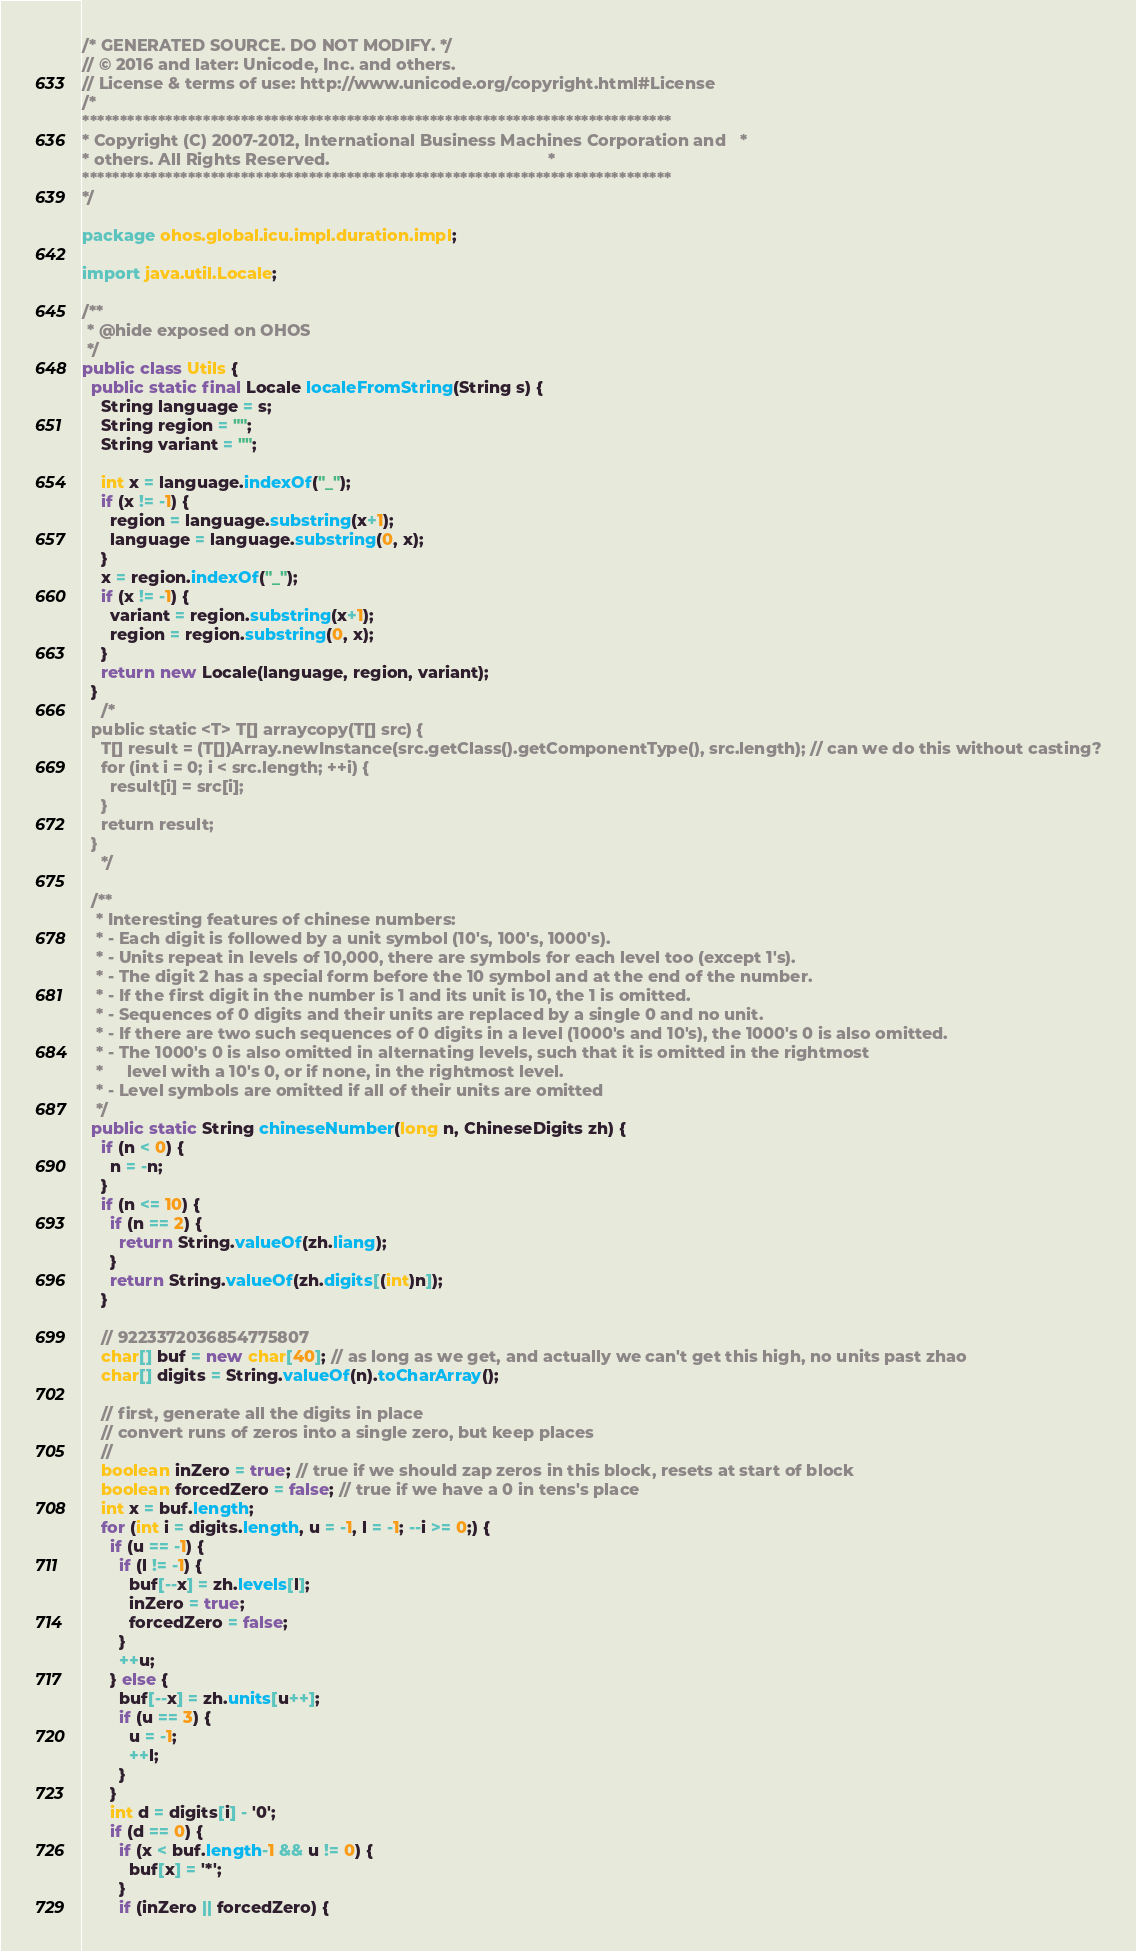<code> <loc_0><loc_0><loc_500><loc_500><_Java_>/* GENERATED SOURCE. DO NOT MODIFY. */
// © 2016 and later: Unicode, Inc. and others.
// License & terms of use: http://www.unicode.org/copyright.html#License
/*
******************************************************************************
* Copyright (C) 2007-2012, International Business Machines Corporation and   *
* others. All Rights Reserved.                                               *
******************************************************************************
*/

package ohos.global.icu.impl.duration.impl;

import java.util.Locale;

/**
 * @hide exposed on OHOS
 */
public class Utils {
  public static final Locale localeFromString(String s) {
    String language = s;
    String region = "";
    String variant = "";

    int x = language.indexOf("_");
    if (x != -1) {
      region = language.substring(x+1);
      language = language.substring(0, x);
    }
    x = region.indexOf("_");
    if (x != -1) {
      variant = region.substring(x+1);
      region = region.substring(0, x);
    }
    return new Locale(language, region, variant);
  }
    /*
  public static <T> T[] arraycopy(T[] src) {
    T[] result = (T[])Array.newInstance(src.getClass().getComponentType(), src.length); // can we do this without casting?
    for (int i = 0; i < src.length; ++i) {
      result[i] = src[i];
    }
    return result;
  }
    */

  /**
   * Interesting features of chinese numbers:
   * - Each digit is followed by a unit symbol (10's, 100's, 1000's).
   * - Units repeat in levels of 10,000, there are symbols for each level too (except 1's).
   * - The digit 2 has a special form before the 10 symbol and at the end of the number.
   * - If the first digit in the number is 1 and its unit is 10, the 1 is omitted.
   * - Sequences of 0 digits and their units are replaced by a single 0 and no unit.
   * - If there are two such sequences of 0 digits in a level (1000's and 10's), the 1000's 0 is also omitted.
   * - The 1000's 0 is also omitted in alternating levels, such that it is omitted in the rightmost
   *     level with a 10's 0, or if none, in the rightmost level.
   * - Level symbols are omitted if all of their units are omitted
   */
  public static String chineseNumber(long n, ChineseDigits zh) {
    if (n < 0) {
      n = -n;
    }
    if (n <= 10) {
      if (n == 2) {
        return String.valueOf(zh.liang);
      }
      return String.valueOf(zh.digits[(int)n]);
    }

    // 9223372036854775807
    char[] buf = new char[40]; // as long as we get, and actually we can't get this high, no units past zhao
    char[] digits = String.valueOf(n).toCharArray();

    // first, generate all the digits in place
    // convert runs of zeros into a single zero, but keep places
    // 
    boolean inZero = true; // true if we should zap zeros in this block, resets at start of block
    boolean forcedZero = false; // true if we have a 0 in tens's place
    int x = buf.length;
    for (int i = digits.length, u = -1, l = -1; --i >= 0;) {
      if (u == -1) {
        if (l != -1) {
          buf[--x] = zh.levels[l];
          inZero = true;
          forcedZero = false;
        }
        ++u;
      } else {
        buf[--x] = zh.units[u++];
        if (u == 3) {
          u = -1;
          ++l;
        }
      }
      int d = digits[i] - '0';
      if (d == 0) {
        if (x < buf.length-1 && u != 0) {
          buf[x] = '*';
        }
        if (inZero || forcedZero) {</code> 